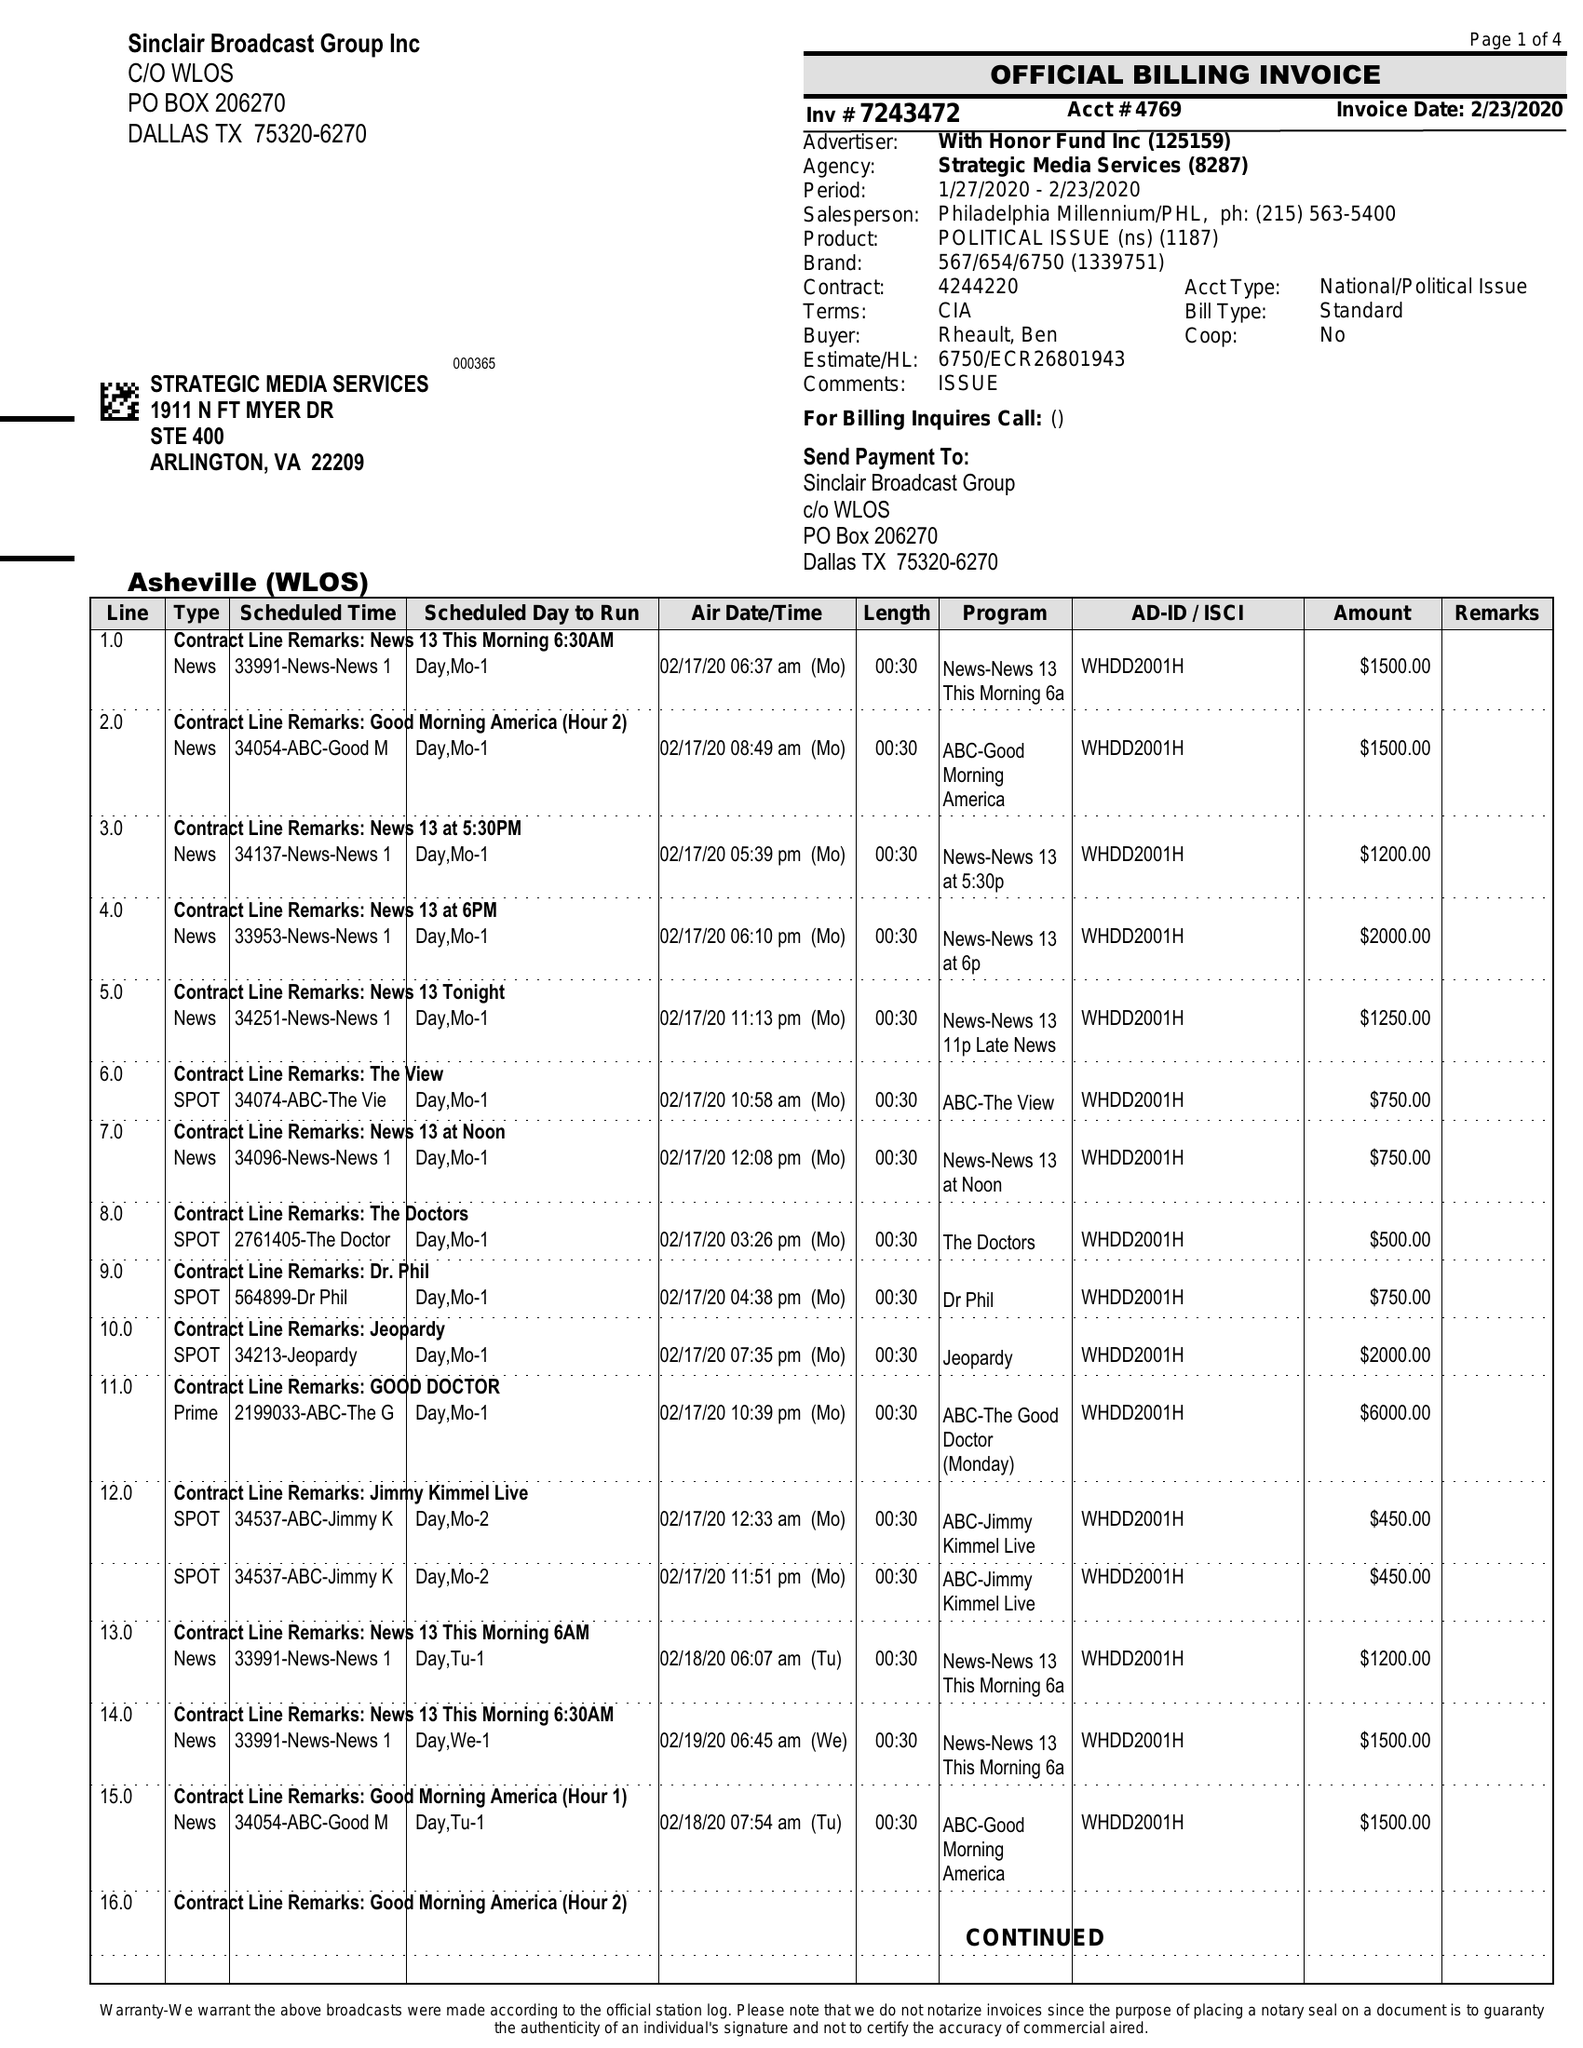What is the value for the gross_amount?
Answer the question using a single word or phrase. 93000.00 